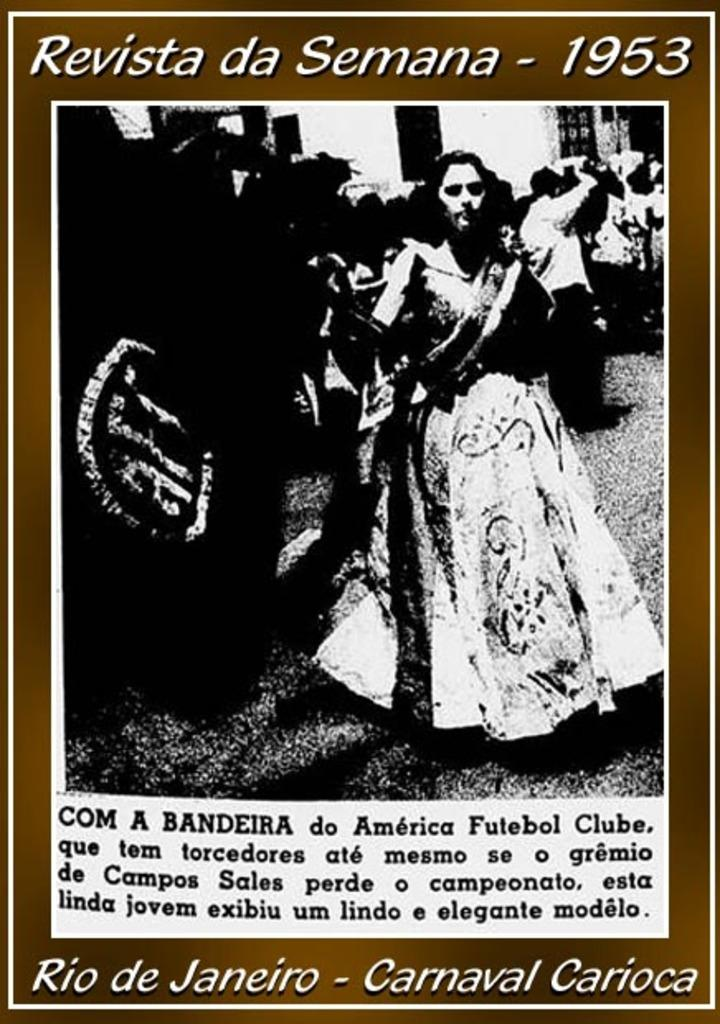What is the color scheme of the image? The image is black and white. What can be seen on the road in the image? There are people standing on the road in the image. What type of impulse can be seen affecting the behavior of the beast in the image? There is no beast present in the image, and therefore no impulse affecting its behavior. 